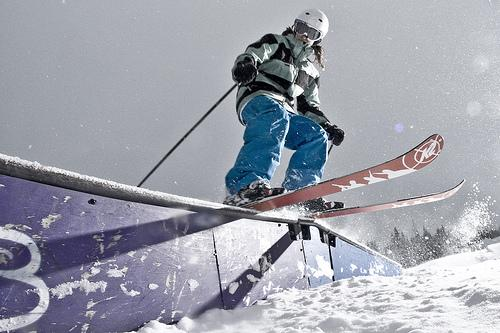Express what is happening in the image using powerful imagery. Amidst a crisp, snowy mountain backdrop, a courageous skier clad in bold gear dares to conquer a spectacular ramp. Mention the most eye-catching element in the image and what that element is doing. A person skiing downhill on a colorful ramp steals the attention, as they perform an action-packed move. Provide a brief description of the primary action taking place in the image. A skier is skiing across a ramp on a snowy mountain, surrounded by trees and wearing protective gear. Explain the location and main activity happening in the image. On a snowy mountain slope, a skier skillfully maneuvers across a vibrant ramp, wearing safety equipment. Summarize the image using adjectives to describe the scene. An exhilarating image of an adventurous skier wearing striking gear while navigating a vivid ramp amidst a snowy landscape. Describe the key components in the image that contribute to the overall action taking place. A skier dressed in protective gear, such as a helmet and goggles, is skiing on a bright ramp in a wintry mountain setting. Describe the image as it would appear in a sports magazine article. The fearless skier, geared up in vibrant attire, tackles the complex ramp with finesse, against a picturesque, snowy mountain backdrop. Share the key elements of the image in a simple manner. A skier crossing a colorful ramp on a snow-covered mountain slope wears a helmet and other protective equipment. State the highlight of the image and what the person is wearing. The focal point is a skier mastering a stunning ramp, donning a white helmet, goggles, and an eye-catching outfit. Narrate the image in a poetic manner. In the embrace of the wintry mountain's breath, a resolute skier clad in luminous armor braves a ramp of vibrant dreams. 